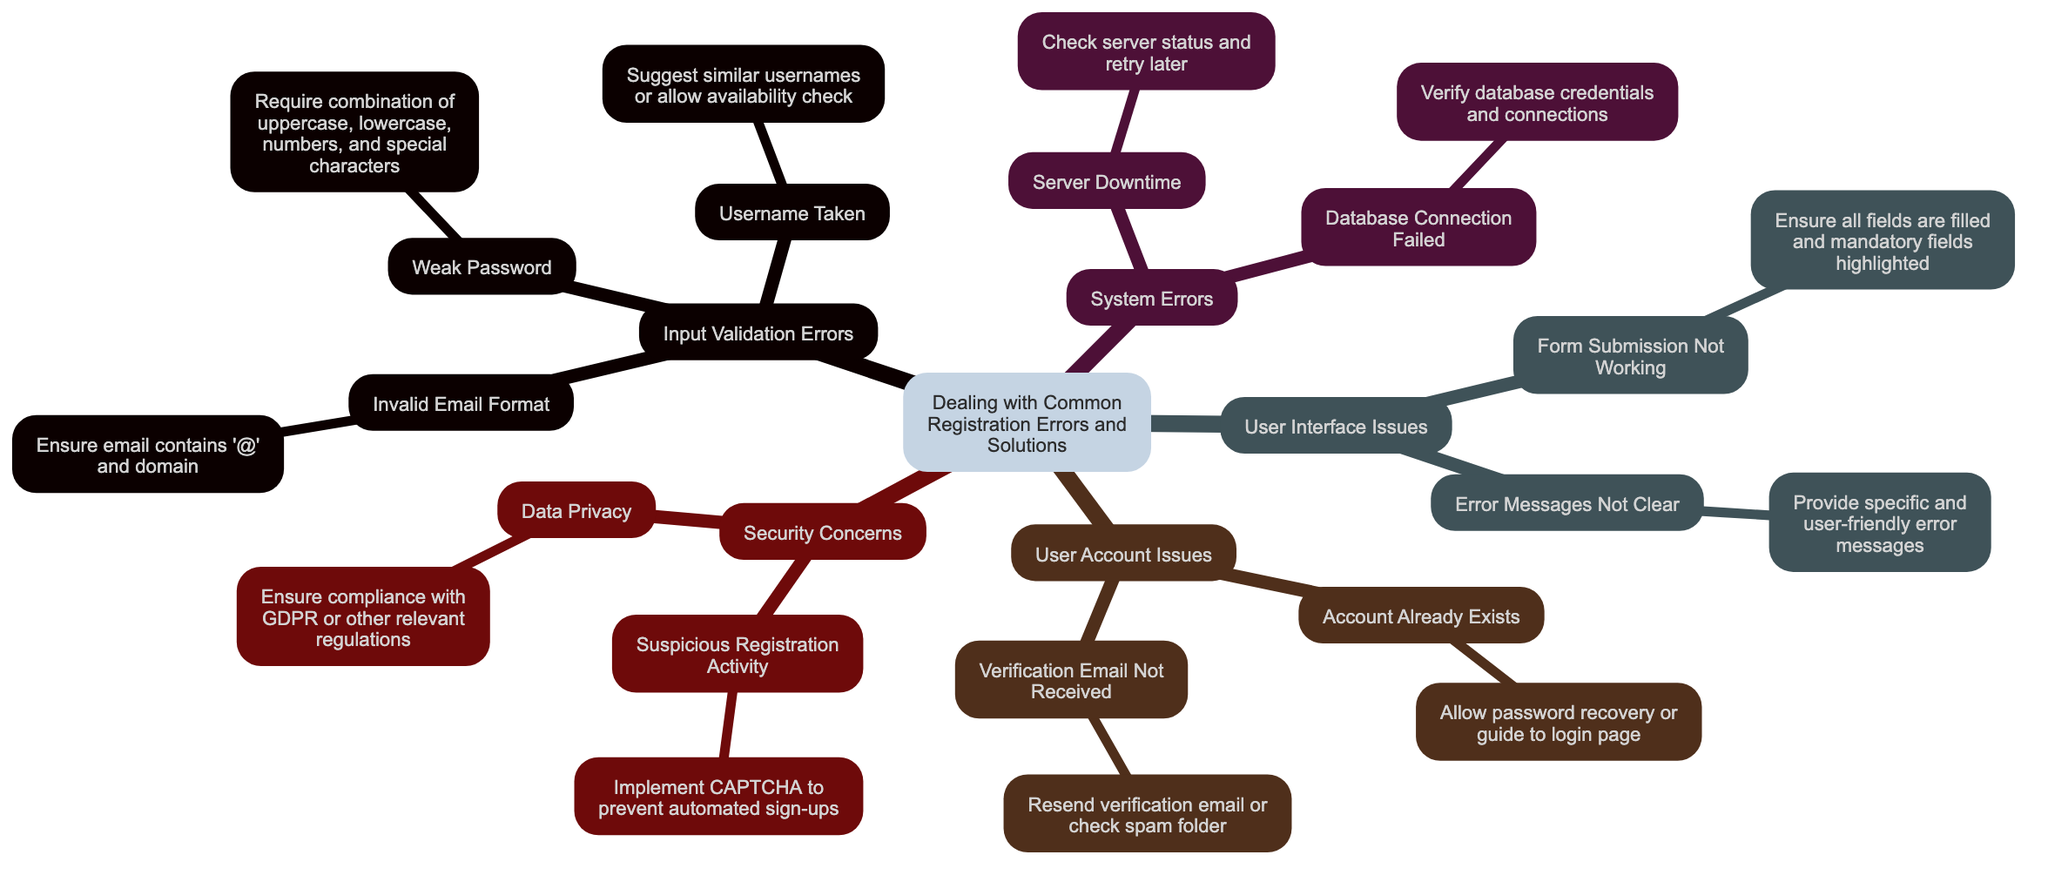What is the central topic of the diagram? The central topic is clearly labeled at the top of the diagram as "Dealing with Common Registration Errors and Solutions," which serves as the main focus from which all branches stem.
Answer: Dealing with Common Registration Errors and Solutions How many branches are there in the diagram? The diagram contains five main branches, which represent the different categories of registration errors and solutions. These branches are Input Validation Errors, System Errors, User Interface Issues, User Account Issues, and Security Concerns.
Answer: 5 What is one solution for "Invalid Email Format"? The solution is stated directly under the "Invalid Email Format" sub-branch as "Ensure email contains '@' and domain." This solution is specific to addressing this particular input validation error.
Answer: Ensure email contains '@' and domain Which branch includes the issue "Server Downtime"? The issue "Server Downtime" is found in the "System Errors" branch, which addresses problems related to server functionality during the registration process.
Answer: System Errors What should be done if "Verification Email Not Received"? Under the "Verification Email Not Received" sub-branch, it is suggested to either "Resend verification email or check spam folder," providing users with actionable steps to solve this problem.
Answer: Resend verification email or check spam folder How does the diagram suggest preventing "Suspicious Registration Activity"? To prevent "Suspicious Registration Activity," the diagram recommends implementing CAPTCHA, which helps to ensure that registrations are being done by real users rather than automated bots.
Answer: Implement CAPTCHA What does the "Weak Password" sub-branch require? The "Weak Password" sub-branch states that passwords should require a combination of uppercase, lowercase, numbers, and special characters, ensuring stronger security for user accounts.
Answer: Require combination of uppercase, lowercase, numbers, and special characters Which sub-branch provides guidance for existing accounts? The "Account Already Exists" sub-branch provides guidance, indicating that users should be allowed to recover their password or be directed to the login page if they attempt to register with an email that is already in use.
Answer: Allow password recovery or guide to login page What is one reason for "Error Messages Not Clear"? The diagram details that the reason for "Error Messages Not Clear" is related to the need for more specific and user-friendly error messages, enhancing user understanding during registration errors.
Answer: Provide specific and user-friendly error messages 